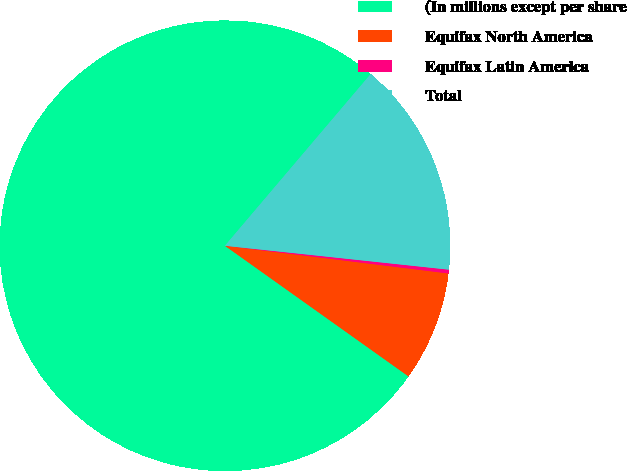Convert chart to OTSL. <chart><loc_0><loc_0><loc_500><loc_500><pie_chart><fcel>(In millions except per share<fcel>Equifax North America<fcel>Equifax Latin America<fcel>Total<nl><fcel>76.35%<fcel>7.88%<fcel>0.27%<fcel>15.49%<nl></chart> 